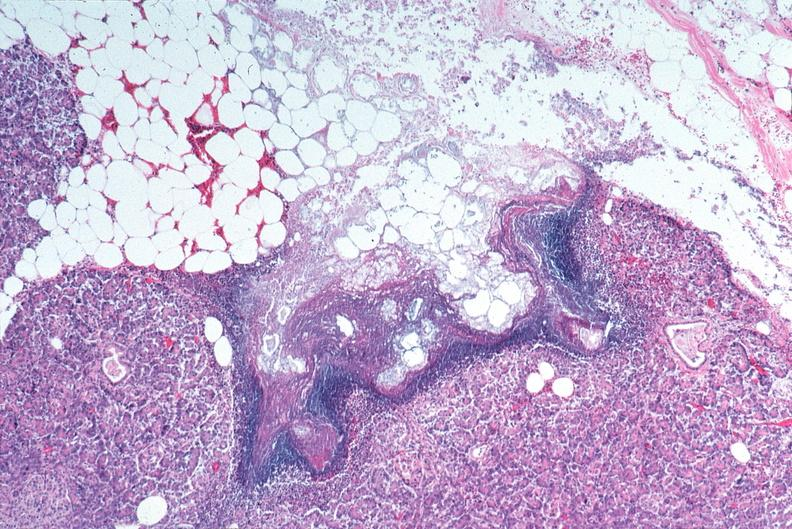does this image show pancreatic fat necrosis?
Answer the question using a single word or phrase. Yes 